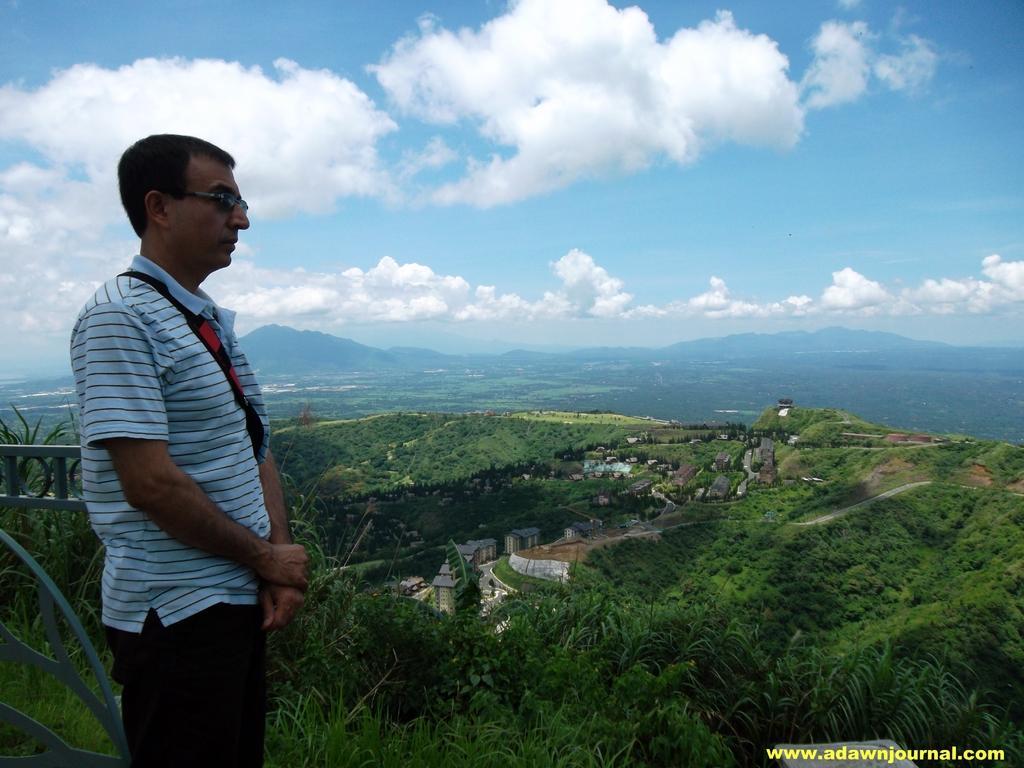Please provide a concise description of this image. In this image I can see the person standing and wearing the specs. In the background I can see many trees and houses. I can also see the mountains, clouds and the sky. 